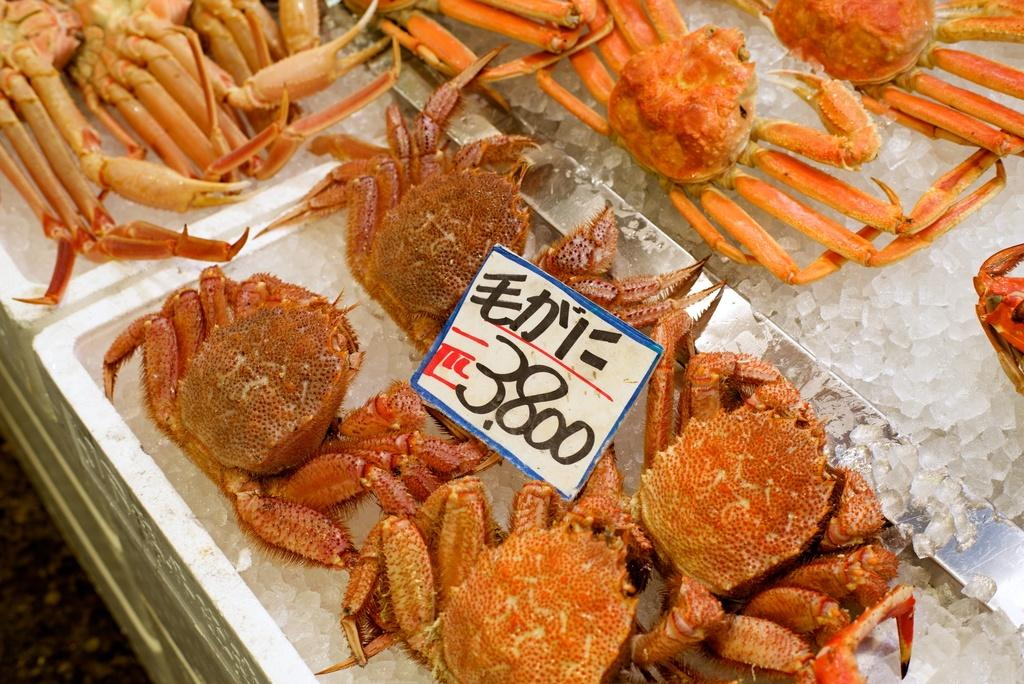What type of objects are present in the ice boxes in the image? There are grabs in the ice boxes in the image. What additional item can be seen in the image? There is a sticker with text and numbers in the image. What type of acoustics can be heard from the glass in the image? There is no glass present in the image, so it is not possible to determine the acoustics. 